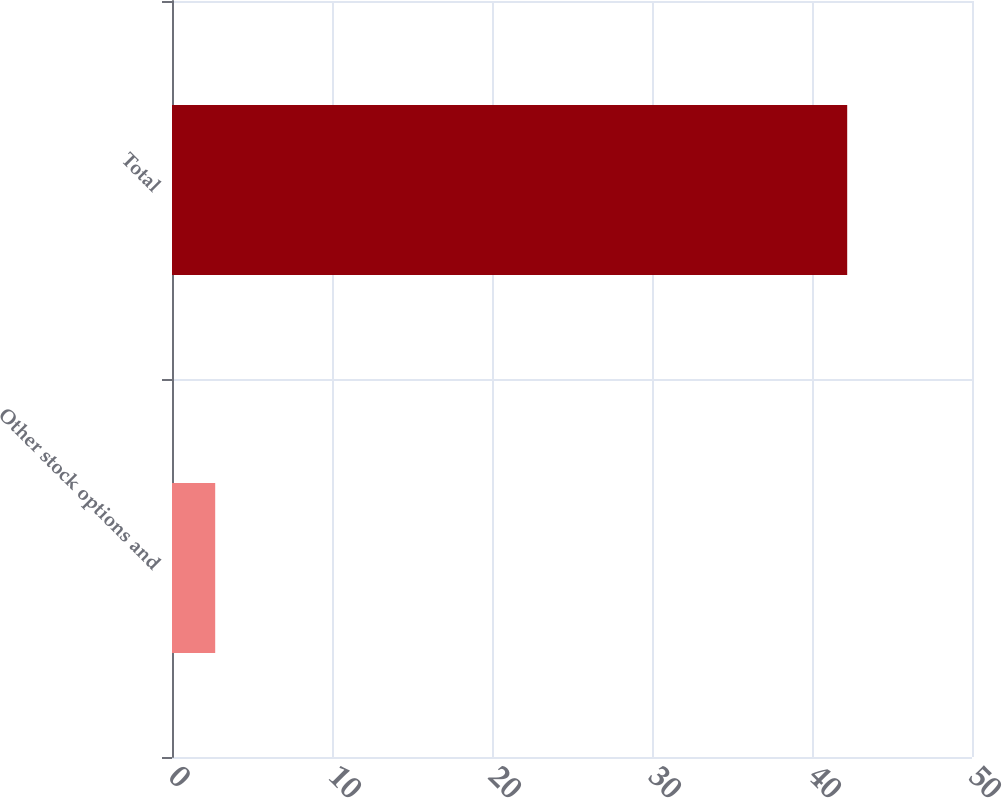Convert chart. <chart><loc_0><loc_0><loc_500><loc_500><bar_chart><fcel>Other stock options and<fcel>Total<nl><fcel>2.7<fcel>42.2<nl></chart> 